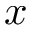Convert formula to latex. <formula><loc_0><loc_0><loc_500><loc_500>x</formula> 